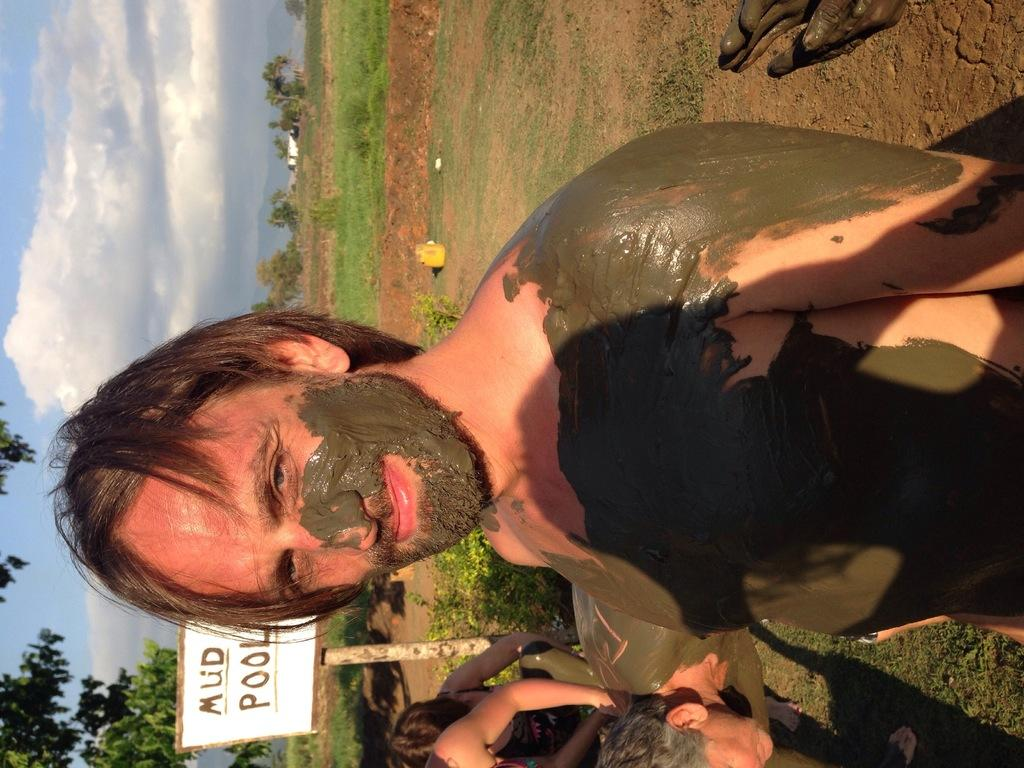Who is present in the image? There is a man in the image. What is the man doing in the image? The man is smiling in the image. What can be seen in the background of the image? There are people, grass, a name board, trees, and the sky visible in the background. What is the condition of the sky in the image? The sky is visible in the background, and clouds are present in it. What type of kettle is being used for teaching in the image? There is no kettle or teaching activity present in the image. What color are the man's lips in the image? The provided facts do not mention the color of the man's lips, so it cannot be determined from the image. 